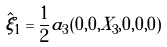Convert formula to latex. <formula><loc_0><loc_0><loc_500><loc_500>\hat { \xi } _ { 1 } = { \frac { 1 } { 2 } } a _ { 3 } ( 0 , 0 , X _ { 3 } , 0 , 0 , 0 )</formula> 